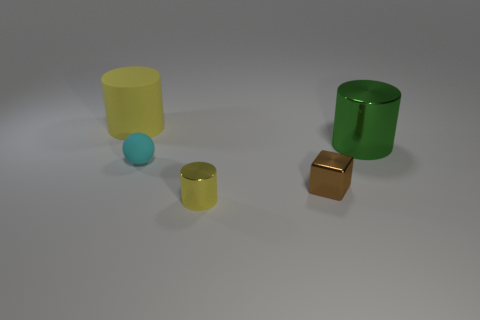Is the big green thing made of the same material as the sphere?
Keep it short and to the point. No. There is another cylinder that is the same size as the green cylinder; what is its material?
Ensure brevity in your answer.  Rubber. How many objects are either yellow things that are on the left side of the tiny cyan rubber sphere or large yellow things?
Your answer should be very brief. 1. Is the number of objects that are behind the rubber sphere the same as the number of large yellow rubber spheres?
Provide a succinct answer. No. Do the tiny shiny cube and the sphere have the same color?
Your answer should be very brief. No. The object that is both behind the tiny brown metallic object and right of the tiny rubber ball is what color?
Your answer should be very brief. Green. How many balls are gray things or tiny cyan things?
Offer a terse response. 1. Are there fewer matte objects that are behind the small cyan matte object than tiny gray blocks?
Ensure brevity in your answer.  No. There is a yellow thing that is the same material as the large green cylinder; what shape is it?
Offer a terse response. Cylinder. What number of tiny shiny things are the same color as the cube?
Provide a succinct answer. 0. 